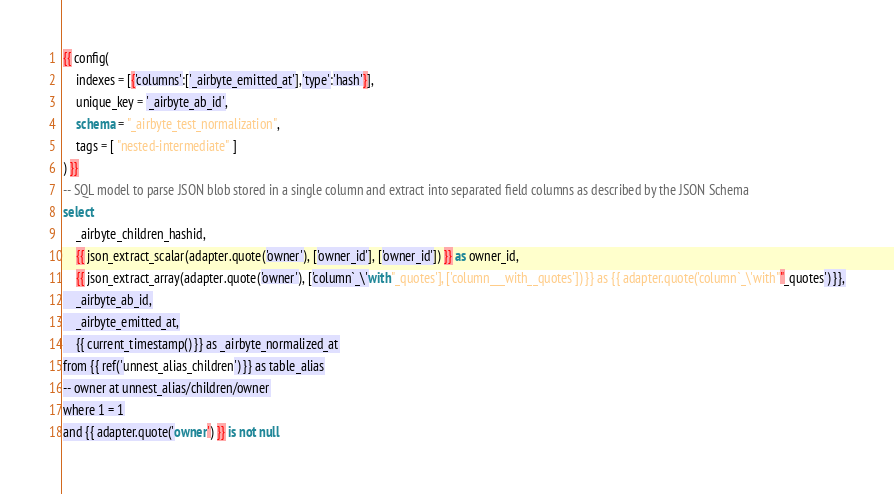<code> <loc_0><loc_0><loc_500><loc_500><_SQL_>{{ config(
    indexes = [{'columns':['_airbyte_emitted_at'],'type':'hash'}],
    unique_key = '_airbyte_ab_id',
    schema = "_airbyte_test_normalization",
    tags = [ "nested-intermediate" ]
) }}
-- SQL model to parse JSON blob stored in a single column and extract into separated field columns as described by the JSON Schema
select
    _airbyte_children_hashid,
    {{ json_extract_scalar(adapter.quote('owner'), ['owner_id'], ['owner_id']) }} as owner_id,
    {{ json_extract_array(adapter.quote('owner'), ['column`_\'with"_quotes'], ['column___with__quotes']) }} as {{ adapter.quote('column`_\'with""_quotes') }},
    _airbyte_ab_id,
    _airbyte_emitted_at,
    {{ current_timestamp() }} as _airbyte_normalized_at
from {{ ref('unnest_alias_children') }} as table_alias
-- owner at unnest_alias/children/owner
where 1 = 1
and {{ adapter.quote('owner') }} is not null

</code> 